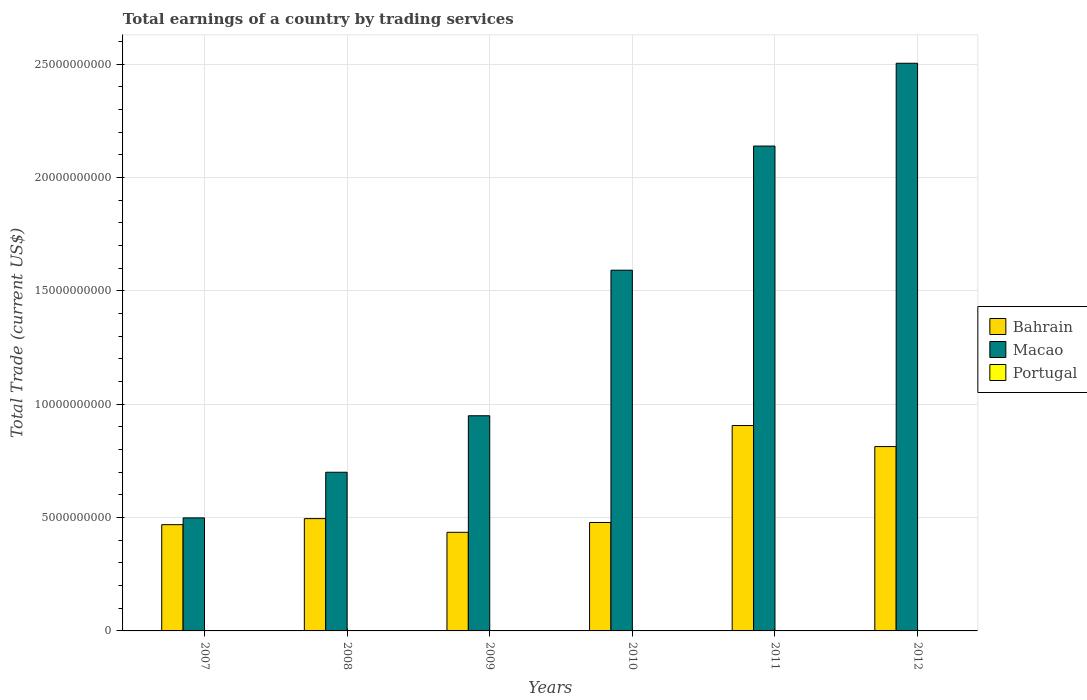How many different coloured bars are there?
Offer a very short reply. 2. How many groups of bars are there?
Your answer should be compact. 6. Are the number of bars per tick equal to the number of legend labels?
Provide a succinct answer. No. What is the label of the 1st group of bars from the left?
Your response must be concise. 2007. What is the total earnings in Bahrain in 2010?
Your answer should be very brief. 4.78e+09. Across all years, what is the maximum total earnings in Bahrain?
Provide a short and direct response. 9.06e+09. Across all years, what is the minimum total earnings in Macao?
Offer a very short reply. 4.99e+09. In which year was the total earnings in Bahrain maximum?
Offer a very short reply. 2011. What is the total total earnings in Bahrain in the graph?
Give a very brief answer. 3.60e+1. What is the difference between the total earnings in Macao in 2009 and that in 2010?
Provide a short and direct response. -6.42e+09. What is the difference between the total earnings in Bahrain in 2011 and the total earnings in Macao in 2008?
Offer a terse response. 2.06e+09. What is the average total earnings in Portugal per year?
Keep it short and to the point. 0. In the year 2009, what is the difference between the total earnings in Macao and total earnings in Bahrain?
Your answer should be very brief. 5.14e+09. In how many years, is the total earnings in Portugal greater than 23000000000 US$?
Ensure brevity in your answer.  0. What is the ratio of the total earnings in Bahrain in 2009 to that in 2012?
Offer a very short reply. 0.53. What is the difference between the highest and the second highest total earnings in Bahrain?
Your answer should be compact. 9.28e+08. What is the difference between the highest and the lowest total earnings in Bahrain?
Provide a short and direct response. 4.71e+09. In how many years, is the total earnings in Bahrain greater than the average total earnings in Bahrain taken over all years?
Make the answer very short. 2. Is the sum of the total earnings in Macao in 2007 and 2011 greater than the maximum total earnings in Bahrain across all years?
Ensure brevity in your answer.  Yes. Is it the case that in every year, the sum of the total earnings in Bahrain and total earnings in Macao is greater than the total earnings in Portugal?
Make the answer very short. Yes. How many years are there in the graph?
Offer a very short reply. 6. Does the graph contain any zero values?
Provide a succinct answer. Yes. How many legend labels are there?
Keep it short and to the point. 3. What is the title of the graph?
Give a very brief answer. Total earnings of a country by trading services. Does "Liechtenstein" appear as one of the legend labels in the graph?
Your answer should be compact. No. What is the label or title of the X-axis?
Offer a very short reply. Years. What is the label or title of the Y-axis?
Keep it short and to the point. Total Trade (current US$). What is the Total Trade (current US$) of Bahrain in 2007?
Give a very brief answer. 4.69e+09. What is the Total Trade (current US$) in Macao in 2007?
Your answer should be very brief. 4.99e+09. What is the Total Trade (current US$) in Portugal in 2007?
Offer a terse response. 0. What is the Total Trade (current US$) in Bahrain in 2008?
Ensure brevity in your answer.  4.96e+09. What is the Total Trade (current US$) of Macao in 2008?
Make the answer very short. 7.00e+09. What is the Total Trade (current US$) of Bahrain in 2009?
Offer a terse response. 4.35e+09. What is the Total Trade (current US$) of Macao in 2009?
Offer a terse response. 9.49e+09. What is the Total Trade (current US$) of Portugal in 2009?
Offer a very short reply. 0. What is the Total Trade (current US$) of Bahrain in 2010?
Give a very brief answer. 4.78e+09. What is the Total Trade (current US$) of Macao in 2010?
Offer a terse response. 1.59e+1. What is the Total Trade (current US$) of Portugal in 2010?
Offer a very short reply. 0. What is the Total Trade (current US$) in Bahrain in 2011?
Offer a very short reply. 9.06e+09. What is the Total Trade (current US$) of Macao in 2011?
Your answer should be compact. 2.14e+1. What is the Total Trade (current US$) of Portugal in 2011?
Ensure brevity in your answer.  0. What is the Total Trade (current US$) of Bahrain in 2012?
Offer a very short reply. 8.13e+09. What is the Total Trade (current US$) in Macao in 2012?
Keep it short and to the point. 2.50e+1. What is the Total Trade (current US$) of Portugal in 2012?
Offer a terse response. 0. Across all years, what is the maximum Total Trade (current US$) of Bahrain?
Provide a succinct answer. 9.06e+09. Across all years, what is the maximum Total Trade (current US$) of Macao?
Keep it short and to the point. 2.50e+1. Across all years, what is the minimum Total Trade (current US$) in Bahrain?
Provide a succinct answer. 4.35e+09. Across all years, what is the minimum Total Trade (current US$) of Macao?
Provide a short and direct response. 4.99e+09. What is the total Total Trade (current US$) of Bahrain in the graph?
Ensure brevity in your answer.  3.60e+1. What is the total Total Trade (current US$) in Macao in the graph?
Offer a terse response. 8.38e+1. What is the difference between the Total Trade (current US$) in Bahrain in 2007 and that in 2008?
Your answer should be very brief. -2.67e+08. What is the difference between the Total Trade (current US$) of Macao in 2007 and that in 2008?
Keep it short and to the point. -2.01e+09. What is the difference between the Total Trade (current US$) of Bahrain in 2007 and that in 2009?
Provide a short and direct response. 3.37e+08. What is the difference between the Total Trade (current US$) in Macao in 2007 and that in 2009?
Provide a succinct answer. -4.51e+09. What is the difference between the Total Trade (current US$) of Bahrain in 2007 and that in 2010?
Give a very brief answer. -9.68e+07. What is the difference between the Total Trade (current US$) of Macao in 2007 and that in 2010?
Your answer should be compact. -1.09e+1. What is the difference between the Total Trade (current US$) of Bahrain in 2007 and that in 2011?
Offer a very short reply. -4.37e+09. What is the difference between the Total Trade (current US$) of Macao in 2007 and that in 2011?
Ensure brevity in your answer.  -1.64e+1. What is the difference between the Total Trade (current US$) of Bahrain in 2007 and that in 2012?
Your answer should be compact. -3.45e+09. What is the difference between the Total Trade (current US$) of Macao in 2007 and that in 2012?
Your answer should be compact. -2.01e+1. What is the difference between the Total Trade (current US$) of Bahrain in 2008 and that in 2009?
Keep it short and to the point. 6.04e+08. What is the difference between the Total Trade (current US$) in Macao in 2008 and that in 2009?
Provide a succinct answer. -2.49e+09. What is the difference between the Total Trade (current US$) of Bahrain in 2008 and that in 2010?
Provide a short and direct response. 1.70e+08. What is the difference between the Total Trade (current US$) in Macao in 2008 and that in 2010?
Provide a succinct answer. -8.92e+09. What is the difference between the Total Trade (current US$) of Bahrain in 2008 and that in 2011?
Your answer should be compact. -4.11e+09. What is the difference between the Total Trade (current US$) in Macao in 2008 and that in 2011?
Offer a very short reply. -1.44e+1. What is the difference between the Total Trade (current US$) of Bahrain in 2008 and that in 2012?
Offer a terse response. -3.18e+09. What is the difference between the Total Trade (current US$) in Macao in 2008 and that in 2012?
Ensure brevity in your answer.  -1.80e+1. What is the difference between the Total Trade (current US$) in Bahrain in 2009 and that in 2010?
Offer a very short reply. -4.34e+08. What is the difference between the Total Trade (current US$) in Macao in 2009 and that in 2010?
Provide a short and direct response. -6.42e+09. What is the difference between the Total Trade (current US$) in Bahrain in 2009 and that in 2011?
Provide a succinct answer. -4.71e+09. What is the difference between the Total Trade (current US$) in Macao in 2009 and that in 2011?
Give a very brief answer. -1.19e+1. What is the difference between the Total Trade (current US$) of Bahrain in 2009 and that in 2012?
Your response must be concise. -3.78e+09. What is the difference between the Total Trade (current US$) in Macao in 2009 and that in 2012?
Offer a very short reply. -1.56e+1. What is the difference between the Total Trade (current US$) in Bahrain in 2010 and that in 2011?
Provide a succinct answer. -4.28e+09. What is the difference between the Total Trade (current US$) in Macao in 2010 and that in 2011?
Make the answer very short. -5.48e+09. What is the difference between the Total Trade (current US$) of Bahrain in 2010 and that in 2012?
Your answer should be very brief. -3.35e+09. What is the difference between the Total Trade (current US$) in Macao in 2010 and that in 2012?
Offer a very short reply. -9.13e+09. What is the difference between the Total Trade (current US$) of Bahrain in 2011 and that in 2012?
Your answer should be very brief. 9.28e+08. What is the difference between the Total Trade (current US$) of Macao in 2011 and that in 2012?
Make the answer very short. -3.65e+09. What is the difference between the Total Trade (current US$) of Bahrain in 2007 and the Total Trade (current US$) of Macao in 2008?
Make the answer very short. -2.31e+09. What is the difference between the Total Trade (current US$) of Bahrain in 2007 and the Total Trade (current US$) of Macao in 2009?
Offer a terse response. -4.81e+09. What is the difference between the Total Trade (current US$) in Bahrain in 2007 and the Total Trade (current US$) in Macao in 2010?
Make the answer very short. -1.12e+1. What is the difference between the Total Trade (current US$) in Bahrain in 2007 and the Total Trade (current US$) in Macao in 2011?
Offer a very short reply. -1.67e+1. What is the difference between the Total Trade (current US$) of Bahrain in 2007 and the Total Trade (current US$) of Macao in 2012?
Make the answer very short. -2.04e+1. What is the difference between the Total Trade (current US$) of Bahrain in 2008 and the Total Trade (current US$) of Macao in 2009?
Your answer should be compact. -4.54e+09. What is the difference between the Total Trade (current US$) in Bahrain in 2008 and the Total Trade (current US$) in Macao in 2010?
Offer a terse response. -1.10e+1. What is the difference between the Total Trade (current US$) of Bahrain in 2008 and the Total Trade (current US$) of Macao in 2011?
Offer a very short reply. -1.64e+1. What is the difference between the Total Trade (current US$) in Bahrain in 2008 and the Total Trade (current US$) in Macao in 2012?
Provide a short and direct response. -2.01e+1. What is the difference between the Total Trade (current US$) in Bahrain in 2009 and the Total Trade (current US$) in Macao in 2010?
Your answer should be compact. -1.16e+1. What is the difference between the Total Trade (current US$) in Bahrain in 2009 and the Total Trade (current US$) in Macao in 2011?
Give a very brief answer. -1.70e+1. What is the difference between the Total Trade (current US$) in Bahrain in 2009 and the Total Trade (current US$) in Macao in 2012?
Make the answer very short. -2.07e+1. What is the difference between the Total Trade (current US$) in Bahrain in 2010 and the Total Trade (current US$) in Macao in 2011?
Offer a terse response. -1.66e+1. What is the difference between the Total Trade (current US$) in Bahrain in 2010 and the Total Trade (current US$) in Macao in 2012?
Your answer should be very brief. -2.03e+1. What is the difference between the Total Trade (current US$) in Bahrain in 2011 and the Total Trade (current US$) in Macao in 2012?
Keep it short and to the point. -1.60e+1. What is the average Total Trade (current US$) of Bahrain per year?
Offer a very short reply. 6.00e+09. What is the average Total Trade (current US$) of Macao per year?
Provide a succinct answer. 1.40e+1. In the year 2007, what is the difference between the Total Trade (current US$) in Bahrain and Total Trade (current US$) in Macao?
Ensure brevity in your answer.  -2.99e+08. In the year 2008, what is the difference between the Total Trade (current US$) of Bahrain and Total Trade (current US$) of Macao?
Offer a terse response. -2.05e+09. In the year 2009, what is the difference between the Total Trade (current US$) in Bahrain and Total Trade (current US$) in Macao?
Offer a very short reply. -5.14e+09. In the year 2010, what is the difference between the Total Trade (current US$) of Bahrain and Total Trade (current US$) of Macao?
Your answer should be very brief. -1.11e+1. In the year 2011, what is the difference between the Total Trade (current US$) of Bahrain and Total Trade (current US$) of Macao?
Make the answer very short. -1.23e+1. In the year 2012, what is the difference between the Total Trade (current US$) of Bahrain and Total Trade (current US$) of Macao?
Keep it short and to the point. -1.69e+1. What is the ratio of the Total Trade (current US$) of Bahrain in 2007 to that in 2008?
Offer a terse response. 0.95. What is the ratio of the Total Trade (current US$) in Macao in 2007 to that in 2008?
Make the answer very short. 0.71. What is the ratio of the Total Trade (current US$) in Bahrain in 2007 to that in 2009?
Ensure brevity in your answer.  1.08. What is the ratio of the Total Trade (current US$) of Macao in 2007 to that in 2009?
Your answer should be very brief. 0.53. What is the ratio of the Total Trade (current US$) in Bahrain in 2007 to that in 2010?
Your response must be concise. 0.98. What is the ratio of the Total Trade (current US$) of Macao in 2007 to that in 2010?
Your response must be concise. 0.31. What is the ratio of the Total Trade (current US$) in Bahrain in 2007 to that in 2011?
Give a very brief answer. 0.52. What is the ratio of the Total Trade (current US$) in Macao in 2007 to that in 2011?
Offer a terse response. 0.23. What is the ratio of the Total Trade (current US$) in Bahrain in 2007 to that in 2012?
Offer a terse response. 0.58. What is the ratio of the Total Trade (current US$) of Macao in 2007 to that in 2012?
Make the answer very short. 0.2. What is the ratio of the Total Trade (current US$) of Bahrain in 2008 to that in 2009?
Provide a short and direct response. 1.14. What is the ratio of the Total Trade (current US$) of Macao in 2008 to that in 2009?
Your answer should be very brief. 0.74. What is the ratio of the Total Trade (current US$) of Bahrain in 2008 to that in 2010?
Offer a very short reply. 1.04. What is the ratio of the Total Trade (current US$) of Macao in 2008 to that in 2010?
Give a very brief answer. 0.44. What is the ratio of the Total Trade (current US$) in Bahrain in 2008 to that in 2011?
Offer a very short reply. 0.55. What is the ratio of the Total Trade (current US$) of Macao in 2008 to that in 2011?
Your response must be concise. 0.33. What is the ratio of the Total Trade (current US$) in Bahrain in 2008 to that in 2012?
Offer a terse response. 0.61. What is the ratio of the Total Trade (current US$) of Macao in 2008 to that in 2012?
Your response must be concise. 0.28. What is the ratio of the Total Trade (current US$) of Bahrain in 2009 to that in 2010?
Your answer should be very brief. 0.91. What is the ratio of the Total Trade (current US$) of Macao in 2009 to that in 2010?
Your answer should be compact. 0.6. What is the ratio of the Total Trade (current US$) of Bahrain in 2009 to that in 2011?
Offer a terse response. 0.48. What is the ratio of the Total Trade (current US$) of Macao in 2009 to that in 2011?
Provide a short and direct response. 0.44. What is the ratio of the Total Trade (current US$) of Bahrain in 2009 to that in 2012?
Your answer should be very brief. 0.53. What is the ratio of the Total Trade (current US$) of Macao in 2009 to that in 2012?
Provide a succinct answer. 0.38. What is the ratio of the Total Trade (current US$) in Bahrain in 2010 to that in 2011?
Keep it short and to the point. 0.53. What is the ratio of the Total Trade (current US$) of Macao in 2010 to that in 2011?
Ensure brevity in your answer.  0.74. What is the ratio of the Total Trade (current US$) of Bahrain in 2010 to that in 2012?
Ensure brevity in your answer.  0.59. What is the ratio of the Total Trade (current US$) of Macao in 2010 to that in 2012?
Make the answer very short. 0.64. What is the ratio of the Total Trade (current US$) in Bahrain in 2011 to that in 2012?
Provide a succinct answer. 1.11. What is the ratio of the Total Trade (current US$) in Macao in 2011 to that in 2012?
Provide a short and direct response. 0.85. What is the difference between the highest and the second highest Total Trade (current US$) of Bahrain?
Keep it short and to the point. 9.28e+08. What is the difference between the highest and the second highest Total Trade (current US$) in Macao?
Keep it short and to the point. 3.65e+09. What is the difference between the highest and the lowest Total Trade (current US$) in Bahrain?
Provide a succinct answer. 4.71e+09. What is the difference between the highest and the lowest Total Trade (current US$) in Macao?
Make the answer very short. 2.01e+1. 